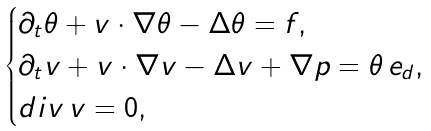Convert formula to latex. <formula><loc_0><loc_0><loc_500><loc_500>\begin{cases} \partial _ { t } \theta + v \cdot \nabla \theta - \Delta \theta = f , \\ \partial _ { t } v + v \cdot \nabla v - \Delta v + \nabla p = \theta \, e _ { d } , \\ d i v \, v = 0 , \end{cases}</formula> 